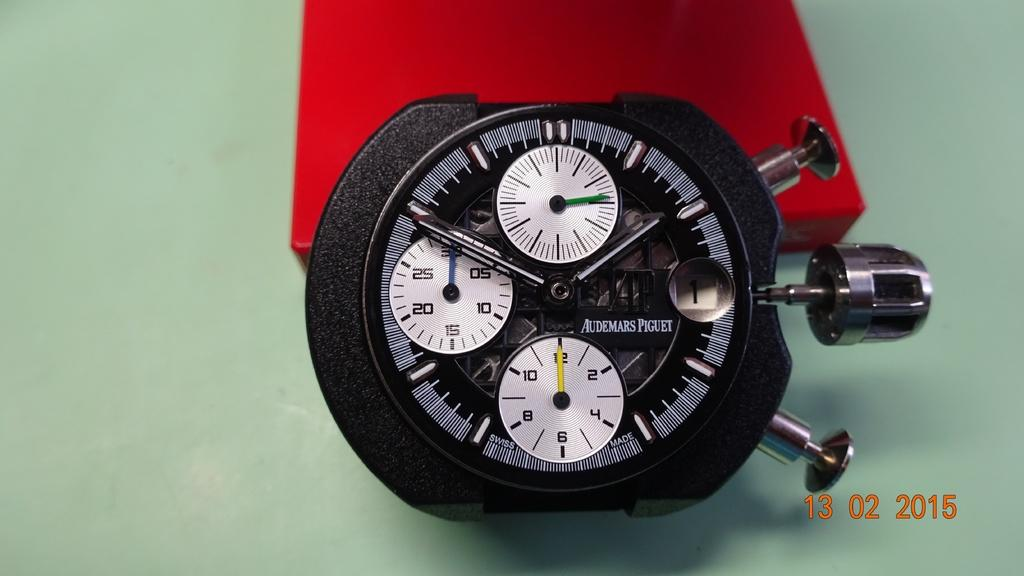<image>
Give a short and clear explanation of the subsequent image. A photo of an Audemars Piguet stopwatch and it's velvet carrying case. 